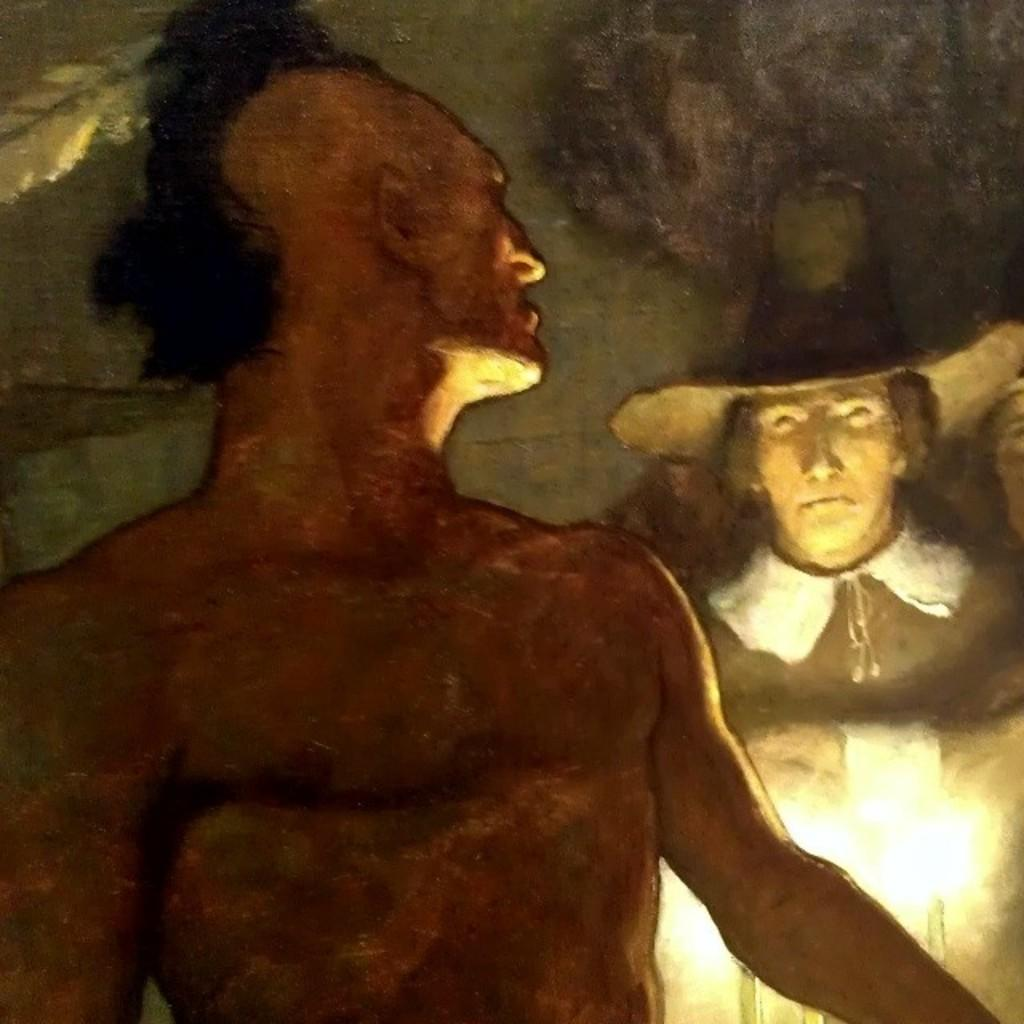What type of artwork is depicted in the image? The image appears to be a painting. Can you describe the subjects in the painting? There are a couple of men in the image. What type of ring is the man wearing in the image? There is no ring visible on any of the men in the image. 